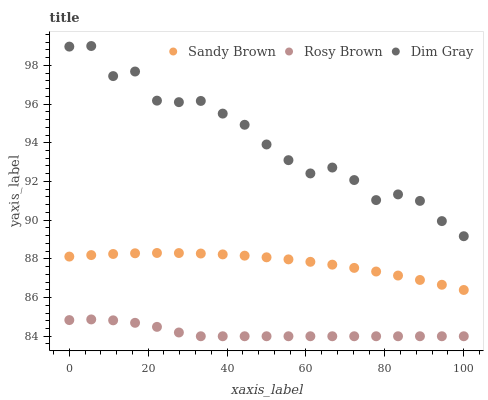Does Rosy Brown have the minimum area under the curve?
Answer yes or no. Yes. Does Dim Gray have the maximum area under the curve?
Answer yes or no. Yes. Does Sandy Brown have the minimum area under the curve?
Answer yes or no. No. Does Sandy Brown have the maximum area under the curve?
Answer yes or no. No. Is Sandy Brown the smoothest?
Answer yes or no. Yes. Is Dim Gray the roughest?
Answer yes or no. Yes. Is Rosy Brown the smoothest?
Answer yes or no. No. Is Rosy Brown the roughest?
Answer yes or no. No. Does Rosy Brown have the lowest value?
Answer yes or no. Yes. Does Sandy Brown have the lowest value?
Answer yes or no. No. Does Dim Gray have the highest value?
Answer yes or no. Yes. Does Sandy Brown have the highest value?
Answer yes or no. No. Is Sandy Brown less than Dim Gray?
Answer yes or no. Yes. Is Dim Gray greater than Sandy Brown?
Answer yes or no. Yes. Does Sandy Brown intersect Dim Gray?
Answer yes or no. No. 